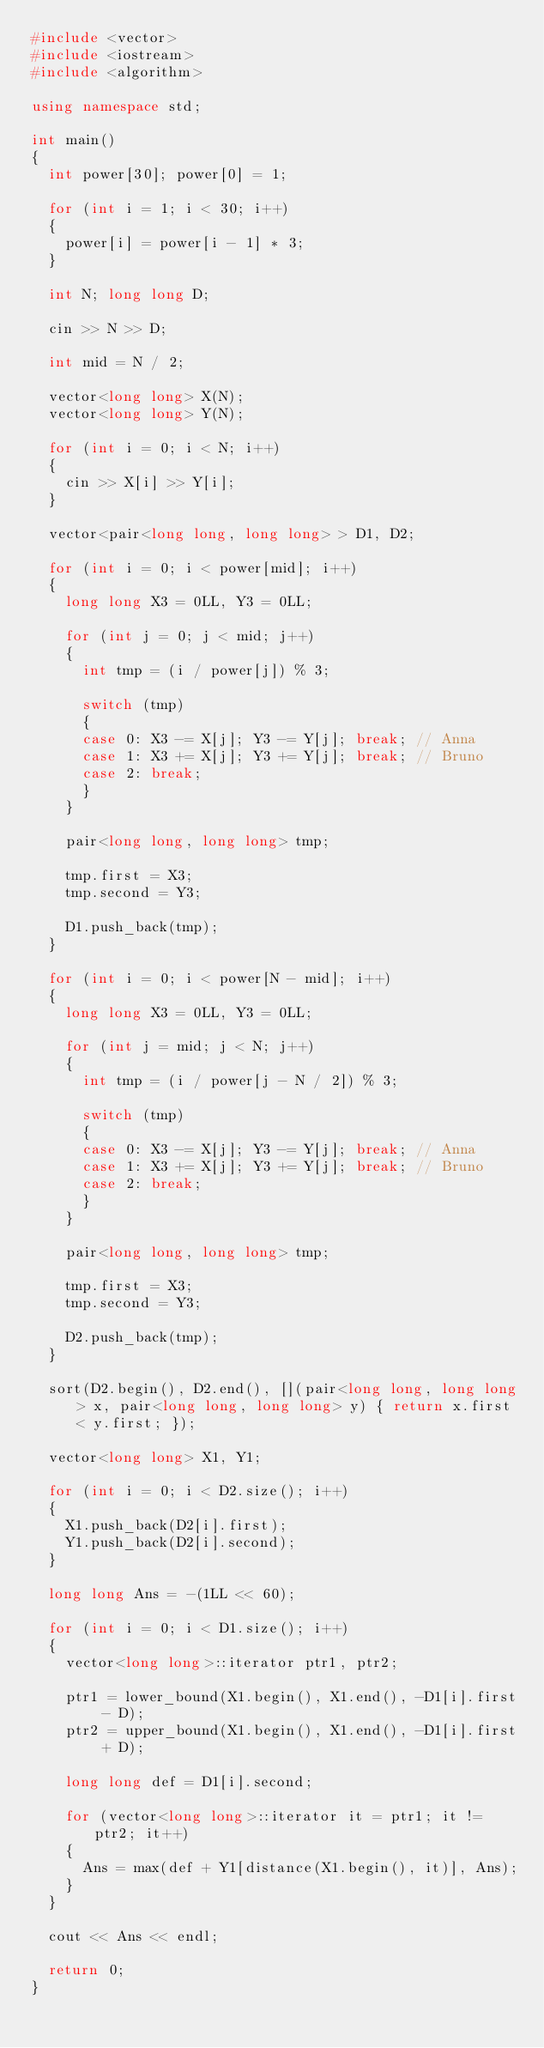<code> <loc_0><loc_0><loc_500><loc_500><_C++_>#include <vector>
#include <iostream>
#include <algorithm>

using namespace std;

int main()
{
	int power[30]; power[0] = 1;

	for (int i = 1; i < 30; i++)
	{
		power[i] = power[i - 1] * 3;
	}

	int N; long long D;

	cin >> N >> D;

	int mid = N / 2;

	vector<long long> X(N);
	vector<long long> Y(N);

	for (int i = 0; i < N; i++)
	{
		cin >> X[i] >> Y[i];
	}

	vector<pair<long long, long long> > D1, D2;

	for (int i = 0; i < power[mid]; i++)
	{
		long long X3 = 0LL, Y3 = 0LL;

		for (int j = 0; j < mid; j++)
		{
			int tmp = (i / power[j]) % 3;

			switch (tmp)
			{
			case 0: X3 -= X[j]; Y3 -= Y[j]; break; // Anna
			case 1: X3 += X[j]; Y3 += Y[j]; break; // Bruno
			case 2: break;
			}
		}

		pair<long long, long long> tmp;

		tmp.first = X3;
		tmp.second = Y3;

		D1.push_back(tmp);
	}

	for (int i = 0; i < power[N - mid]; i++)
	{
		long long X3 = 0LL, Y3 = 0LL;

		for (int j = mid; j < N; j++)
		{
			int tmp = (i / power[j - N / 2]) % 3;

			switch (tmp)
			{
			case 0: X3 -= X[j]; Y3 -= Y[j]; break; // Anna
			case 1: X3 += X[j]; Y3 += Y[j]; break; // Bruno
			case 2: break;
			}
		}

		pair<long long, long long> tmp;

		tmp.first = X3;
		tmp.second = Y3;

		D2.push_back(tmp);
	}

	sort(D2.begin(), D2.end(), [](pair<long long, long long> x, pair<long long, long long> y) { return x.first < y.first; });

	vector<long long> X1, Y1;

	for (int i = 0; i < D2.size(); i++)
	{
		X1.push_back(D2[i].first);
		Y1.push_back(D2[i].second);
	}

	long long Ans = -(1LL << 60);

	for (int i = 0; i < D1.size(); i++)
	{
		vector<long long>::iterator ptr1, ptr2;

		ptr1 = lower_bound(X1.begin(), X1.end(), -D1[i].first - D);
		ptr2 = upper_bound(X1.begin(), X1.end(), -D1[i].first + D);

		long long def = D1[i].second;

		for (vector<long long>::iterator it = ptr1; it != ptr2; it++)
		{
			Ans = max(def + Y1[distance(X1.begin(), it)], Ans);
		}
	}

	cout << Ans << endl;

	return 0;
}</code> 